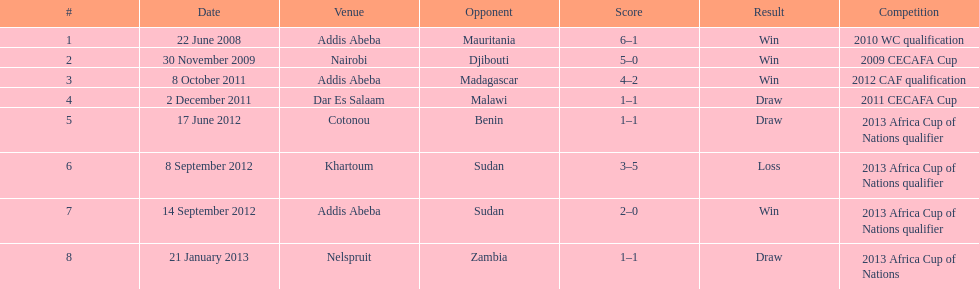Number of different teams listed on the chart 7. 